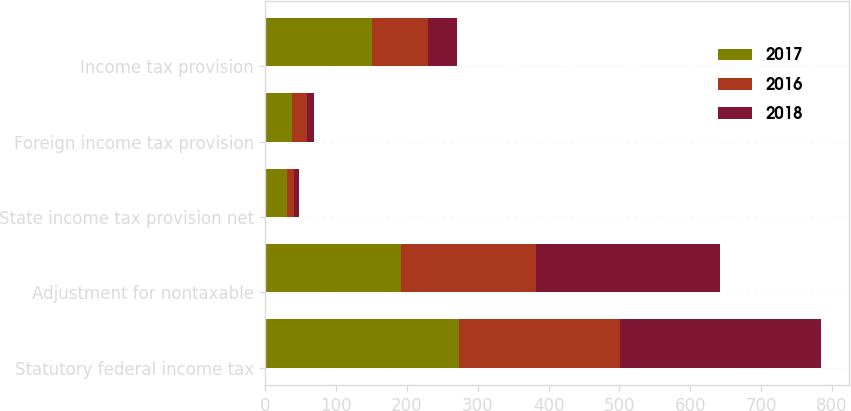<chart> <loc_0><loc_0><loc_500><loc_500><stacked_bar_chart><ecel><fcel>Statutory federal income tax<fcel>Adjustment for nontaxable<fcel>State income tax provision net<fcel>Foreign income tax provision<fcel>Income tax provision<nl><fcel>2017<fcel>273<fcel>192<fcel>31<fcel>38<fcel>150<nl><fcel>2016<fcel>228<fcel>190<fcel>10<fcel>21<fcel>80<nl><fcel>2018<fcel>284<fcel>260<fcel>7<fcel>9<fcel>40<nl></chart> 